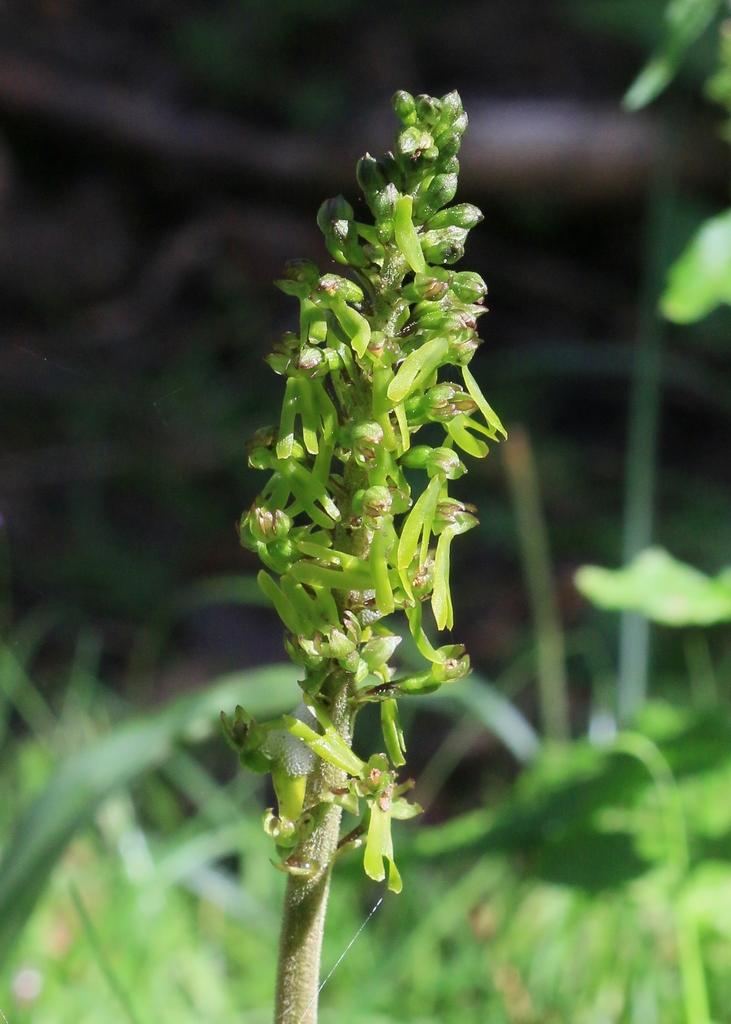What type of plant is visible in the image? There is a plant in the image. What type of vegetation is present in the image? There is grass in the image. What part of the plant is visible in the image? There are leaves in the image. How many bubbles can be seen floating around the plant in the image? There are no bubbles present in the image. Can you see a cat interacting with the plant in the image? There is no cat present in the image. 